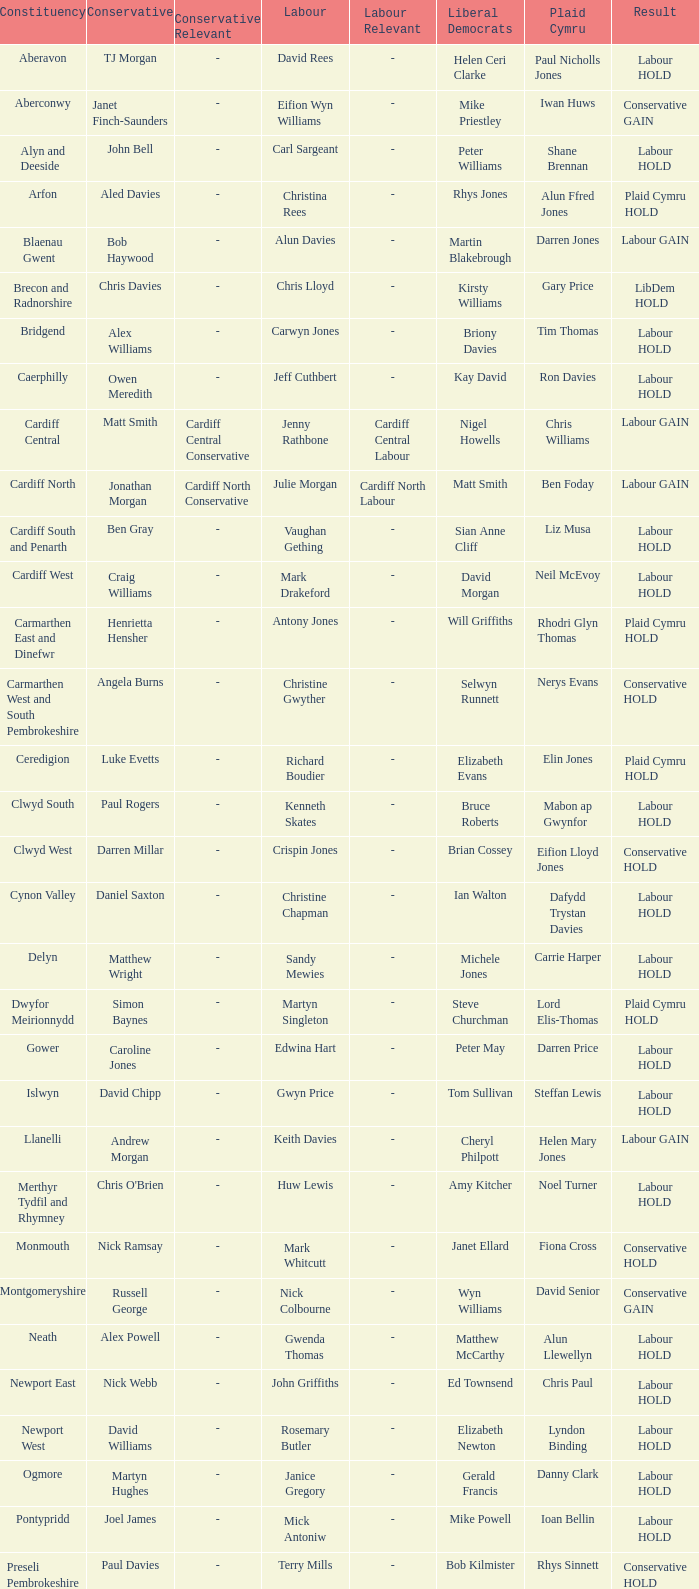Can you parse all the data within this table? {'header': ['Constituency', 'Conservative', 'Conservative Relevant', 'Labour', 'Labour Relevant', 'Liberal Democrats', 'Plaid Cymru', 'Result'], 'rows': [['Aberavon', 'TJ Morgan', '-', 'David Rees', '-', 'Helen Ceri Clarke', 'Paul Nicholls Jones', 'Labour HOLD'], ['Aberconwy', 'Janet Finch-Saunders', '-', 'Eifion Wyn Williams', '-', 'Mike Priestley', 'Iwan Huws', 'Conservative GAIN'], ['Alyn and Deeside', 'John Bell', '-', 'Carl Sargeant', '-', 'Peter Williams', 'Shane Brennan', 'Labour HOLD'], ['Arfon', 'Aled Davies', '-', 'Christina Rees', '-', 'Rhys Jones', 'Alun Ffred Jones', 'Plaid Cymru HOLD'], ['Blaenau Gwent', 'Bob Haywood', '-', 'Alun Davies', '-', 'Martin Blakebrough', 'Darren Jones', 'Labour GAIN'], ['Brecon and Radnorshire', 'Chris Davies', '-', 'Chris Lloyd', '-', 'Kirsty Williams', 'Gary Price', 'LibDem HOLD'], ['Bridgend', 'Alex Williams', '-', 'Carwyn Jones', '-', 'Briony Davies', 'Tim Thomas', 'Labour HOLD'], ['Caerphilly', 'Owen Meredith', '-', 'Jeff Cuthbert', '-', 'Kay David', 'Ron Davies', 'Labour HOLD'], ['Cardiff Central', 'Matt Smith', 'Cardiff Central Conservative', 'Jenny Rathbone', 'Cardiff Central Labour', 'Nigel Howells', 'Chris Williams', 'Labour GAIN'], ['Cardiff North', 'Jonathan Morgan', 'Cardiff North Conservative', 'Julie Morgan', 'Cardiff North Labour', 'Matt Smith', 'Ben Foday', 'Labour GAIN'], ['Cardiff South and Penarth', 'Ben Gray', '-', 'Vaughan Gething', '-', 'Sian Anne Cliff', 'Liz Musa', 'Labour HOLD'], ['Cardiff West', 'Craig Williams', '-', 'Mark Drakeford', '-', 'David Morgan', 'Neil McEvoy', 'Labour HOLD'], ['Carmarthen East and Dinefwr', 'Henrietta Hensher', '-', 'Antony Jones', '-', 'Will Griffiths', 'Rhodri Glyn Thomas', 'Plaid Cymru HOLD'], ['Carmarthen West and South Pembrokeshire', 'Angela Burns', '-', 'Christine Gwyther', '-', 'Selwyn Runnett', 'Nerys Evans', 'Conservative HOLD'], ['Ceredigion', 'Luke Evetts', '-', 'Richard Boudier', '-', 'Elizabeth Evans', 'Elin Jones', 'Plaid Cymru HOLD'], ['Clwyd South', 'Paul Rogers', '-', 'Kenneth Skates', '-', 'Bruce Roberts', 'Mabon ap Gwynfor', 'Labour HOLD'], ['Clwyd West', 'Darren Millar', '-', 'Crispin Jones', '-', 'Brian Cossey', 'Eifion Lloyd Jones', 'Conservative HOLD'], ['Cynon Valley', 'Daniel Saxton', '-', 'Christine Chapman', '-', 'Ian Walton', 'Dafydd Trystan Davies', 'Labour HOLD'], ['Delyn', 'Matthew Wright', '-', 'Sandy Mewies', '-', 'Michele Jones', 'Carrie Harper', 'Labour HOLD'], ['Dwyfor Meirionnydd', 'Simon Baynes', '-', 'Martyn Singleton', '-', 'Steve Churchman', 'Lord Elis-Thomas', 'Plaid Cymru HOLD'], ['Gower', 'Caroline Jones', '-', 'Edwina Hart', '-', 'Peter May', 'Darren Price', 'Labour HOLD'], ['Islwyn', 'David Chipp', '-', 'Gwyn Price', '-', 'Tom Sullivan', 'Steffan Lewis', 'Labour HOLD'], ['Llanelli', 'Andrew Morgan', '-', 'Keith Davies', '-', 'Cheryl Philpott', 'Helen Mary Jones', 'Labour GAIN'], ['Merthyr Tydfil and Rhymney', "Chris O'Brien", '-', 'Huw Lewis', '-', 'Amy Kitcher', 'Noel Turner', 'Labour HOLD'], ['Monmouth', 'Nick Ramsay', '-', 'Mark Whitcutt', '-', 'Janet Ellard', 'Fiona Cross', 'Conservative HOLD'], ['Montgomeryshire', 'Russell George', '-', 'Nick Colbourne', '-', 'Wyn Williams', 'David Senior', 'Conservative GAIN'], ['Neath', 'Alex Powell', '-', 'Gwenda Thomas', '-', 'Matthew McCarthy', 'Alun Llewellyn', 'Labour HOLD'], ['Newport East', 'Nick Webb', '-', 'John Griffiths', '-', 'Ed Townsend', 'Chris Paul', 'Labour HOLD'], ['Newport West', 'David Williams', '-', 'Rosemary Butler', '-', 'Elizabeth Newton', 'Lyndon Binding', 'Labour HOLD'], ['Ogmore', 'Martyn Hughes', '-', 'Janice Gregory', '-', 'Gerald Francis', 'Danny Clark', 'Labour HOLD'], ['Pontypridd', 'Joel James', '-', 'Mick Antoniw', '-', 'Mike Powell', 'Ioan Bellin', 'Labour HOLD'], ['Preseli Pembrokeshire', 'Paul Davies', '-', 'Terry Mills', '-', 'Bob Kilmister', 'Rhys Sinnett', 'Conservative HOLD'], ['Rhondda', 'James Eric Jefferys', '-', 'Leighton Andrews', '-', 'George Summers', 'Sera Evans-Fear', 'Labour HOLD'], ['Swansea East', 'Dan Boucher', '-', 'Michael Hedges', '-', 'Sam Samuel', 'Dic Jones', 'Labour HOLD'], ['Swansea West', 'Stephen Jenkins', '-', 'Julie James', '-', 'Rob Speht', 'Carl Harris', 'Labour HOLD'], ['Torfaen', 'Natasha Asghar', '-', 'Lynne Neagle', '-', 'Will Griffiths', 'Jeff Rees', 'Labour HOLD'], ['Vale of Clwyd', 'Ian Gunning', '-', 'Ann Jones', '-', 'Heather Prydderch', 'Alun Lloyd Jones', 'Labour HOLD'], ['Vale of Glamorgan', 'Angela Jones-Evans', '-', 'Jane Hutt', '-', 'Damian Chick', 'Ian Johnson', 'Labour HOLD'], ['Wrexham', 'John Marek', '-', 'Lesley Griffiths', '-', 'Bill Brereton', 'Marc Jones', 'Labour HOLD'], ['Ynys Môn', 'Paul Williams', '-', 'Joe Lock', '-', 'Rhys Taylor', 'Ieuan Wyn Jones', 'Plaid Cymru HOLD']]} In what constituency was the result labour hold and Liberal democrat Elizabeth Newton won? Newport West. 